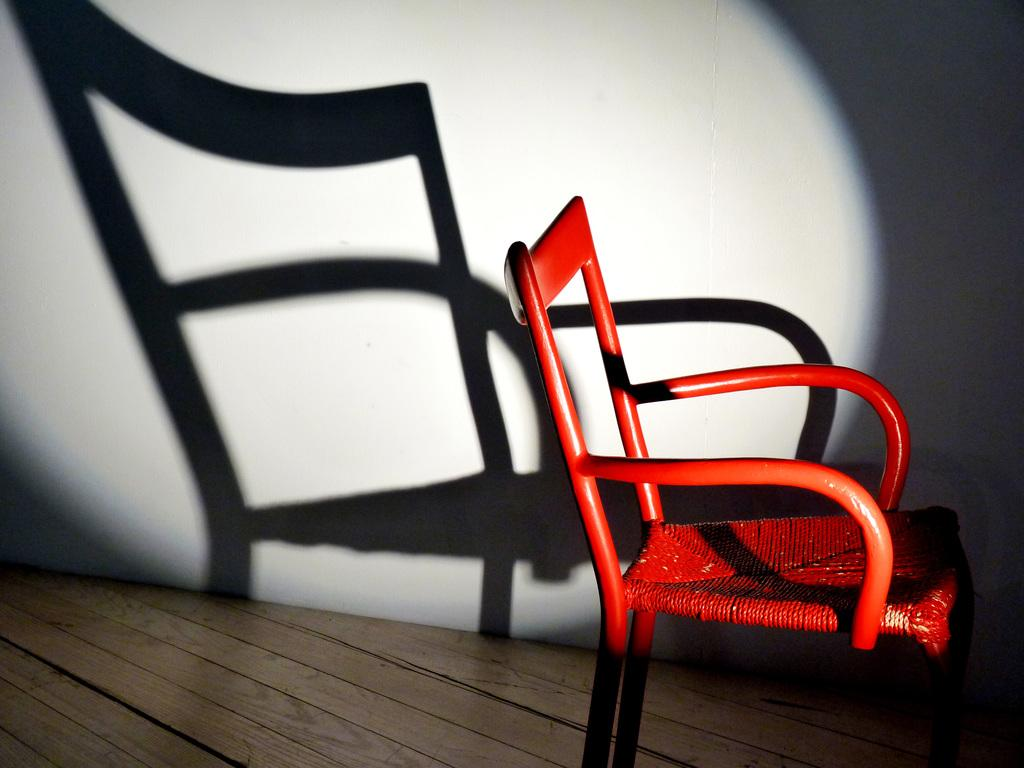What can be seen in the background of the image? There is a wall in the background of the image. What is the shadow in the image a shadow of? The shadow in the image is a shadow of a chair. Where is the chair located in the image? The chair is on the floor in the image. What color is the chair? The chair is red in color. Reasoning: Let's think step by step by step in order to produce the conversation. We start by identifying the main subjects and objects in the image based on the provided facts. We then formulate questions that focus on the location and characteristics of these subjects and objects, ensuring that each question can be answered definitively with the information given. We avoid yes/no questions and ensure that the language is simple and clear. Absurd Question/Answer: What time of day is it in the image, given the presence of a lamp? There is no lamp present in the image, so it is not possible to determine the time of day based on that information. How many slaves are visible in the image? There are no slaves present in the image. What type of lamp is on the table in the image? There is no lamp present in the image. 